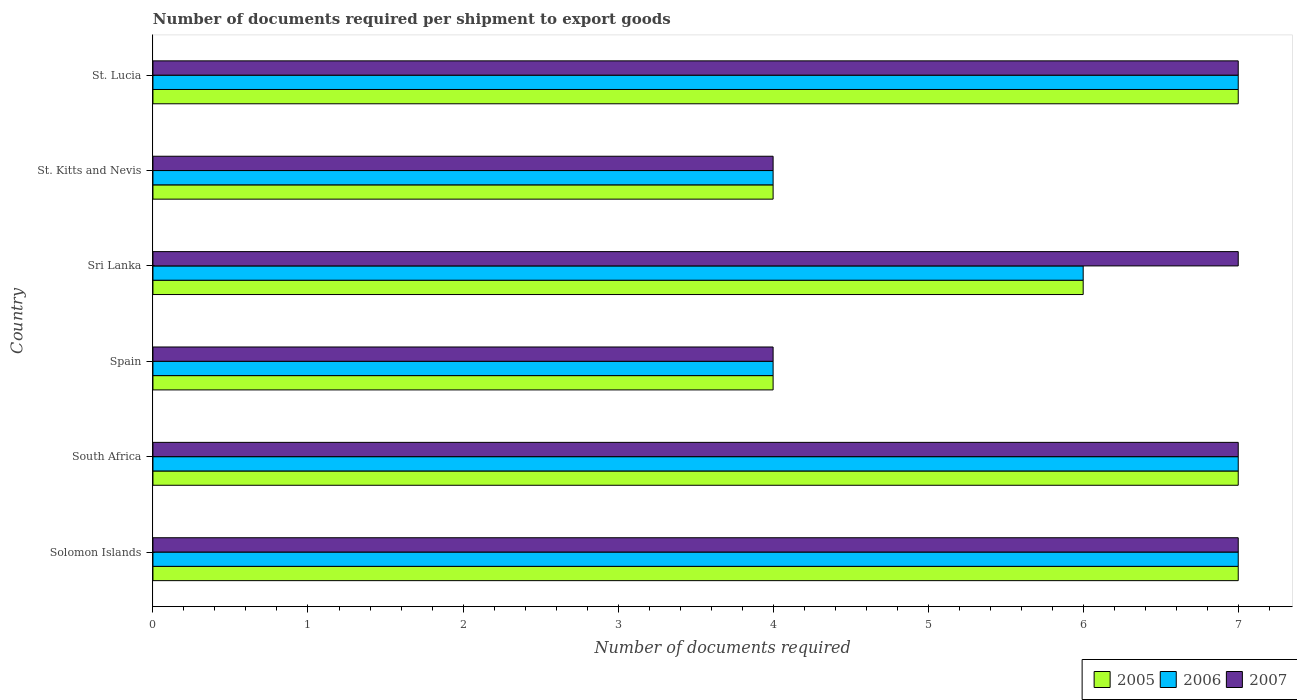How many groups of bars are there?
Provide a short and direct response. 6. Are the number of bars per tick equal to the number of legend labels?
Your response must be concise. Yes. Are the number of bars on each tick of the Y-axis equal?
Ensure brevity in your answer.  Yes. How many bars are there on the 5th tick from the top?
Ensure brevity in your answer.  3. How many bars are there on the 6th tick from the bottom?
Provide a succinct answer. 3. What is the label of the 6th group of bars from the top?
Your answer should be compact. Solomon Islands. In how many cases, is the number of bars for a given country not equal to the number of legend labels?
Give a very brief answer. 0. In which country was the number of documents required per shipment to export goods in 2006 maximum?
Make the answer very short. Solomon Islands. In which country was the number of documents required per shipment to export goods in 2006 minimum?
Offer a very short reply. Spain. What is the total number of documents required per shipment to export goods in 2007 in the graph?
Your answer should be very brief. 36. What is the difference between the number of documents required per shipment to export goods in 2006 in Solomon Islands and that in St. Kitts and Nevis?
Offer a very short reply. 3. What is the difference between the number of documents required per shipment to export goods in 2006 in Sri Lanka and the number of documents required per shipment to export goods in 2005 in St. Kitts and Nevis?
Provide a short and direct response. 2. What is the average number of documents required per shipment to export goods in 2005 per country?
Ensure brevity in your answer.  5.83. What is the difference between the number of documents required per shipment to export goods in 2006 and number of documents required per shipment to export goods in 2007 in St. Lucia?
Your answer should be compact. 0. What is the difference between the highest and the lowest number of documents required per shipment to export goods in 2006?
Give a very brief answer. 3. Is the sum of the number of documents required per shipment to export goods in 2006 in St. Kitts and Nevis and St. Lucia greater than the maximum number of documents required per shipment to export goods in 2007 across all countries?
Make the answer very short. Yes. What does the 1st bar from the bottom in Spain represents?
Your answer should be very brief. 2005. How many bars are there?
Give a very brief answer. 18. Are the values on the major ticks of X-axis written in scientific E-notation?
Offer a very short reply. No. How many legend labels are there?
Provide a succinct answer. 3. How are the legend labels stacked?
Provide a short and direct response. Horizontal. What is the title of the graph?
Your answer should be compact. Number of documents required per shipment to export goods. Does "2001" appear as one of the legend labels in the graph?
Provide a short and direct response. No. What is the label or title of the X-axis?
Your answer should be very brief. Number of documents required. What is the Number of documents required of 2005 in Solomon Islands?
Give a very brief answer. 7. What is the Number of documents required in 2006 in Solomon Islands?
Your response must be concise. 7. What is the Number of documents required of 2005 in South Africa?
Provide a short and direct response. 7. What is the Number of documents required in 2005 in Spain?
Provide a succinct answer. 4. What is the Number of documents required of 2006 in Spain?
Provide a short and direct response. 4. What is the Number of documents required of 2007 in Spain?
Make the answer very short. 4. What is the Number of documents required of 2005 in Sri Lanka?
Provide a succinct answer. 6. What is the Number of documents required of 2006 in St. Kitts and Nevis?
Provide a succinct answer. 4. What is the Number of documents required of 2005 in St. Lucia?
Offer a very short reply. 7. What is the Number of documents required of 2007 in St. Lucia?
Your answer should be compact. 7. Across all countries, what is the maximum Number of documents required of 2005?
Offer a very short reply. 7. Across all countries, what is the minimum Number of documents required in 2006?
Provide a short and direct response. 4. What is the total Number of documents required of 2005 in the graph?
Ensure brevity in your answer.  35. What is the total Number of documents required in 2007 in the graph?
Provide a short and direct response. 36. What is the difference between the Number of documents required in 2005 in Solomon Islands and that in Spain?
Provide a short and direct response. 3. What is the difference between the Number of documents required of 2007 in Solomon Islands and that in Spain?
Offer a very short reply. 3. What is the difference between the Number of documents required of 2006 in Solomon Islands and that in Sri Lanka?
Provide a succinct answer. 1. What is the difference between the Number of documents required in 2005 in Solomon Islands and that in St. Kitts and Nevis?
Your response must be concise. 3. What is the difference between the Number of documents required of 2007 in Solomon Islands and that in St. Kitts and Nevis?
Offer a terse response. 3. What is the difference between the Number of documents required of 2007 in Solomon Islands and that in St. Lucia?
Offer a very short reply. 0. What is the difference between the Number of documents required in 2005 in South Africa and that in Spain?
Make the answer very short. 3. What is the difference between the Number of documents required of 2006 in South Africa and that in Spain?
Your response must be concise. 3. What is the difference between the Number of documents required of 2007 in South Africa and that in Spain?
Keep it short and to the point. 3. What is the difference between the Number of documents required in 2005 in South Africa and that in Sri Lanka?
Keep it short and to the point. 1. What is the difference between the Number of documents required of 2005 in South Africa and that in St. Kitts and Nevis?
Your response must be concise. 3. What is the difference between the Number of documents required of 2005 in South Africa and that in St. Lucia?
Make the answer very short. 0. What is the difference between the Number of documents required of 2006 in South Africa and that in St. Lucia?
Make the answer very short. 0. What is the difference between the Number of documents required in 2005 in Spain and that in Sri Lanka?
Offer a terse response. -2. What is the difference between the Number of documents required of 2005 in Spain and that in St. Kitts and Nevis?
Ensure brevity in your answer.  0. What is the difference between the Number of documents required in 2006 in Sri Lanka and that in St. Kitts and Nevis?
Offer a terse response. 2. What is the difference between the Number of documents required of 2006 in Sri Lanka and that in St. Lucia?
Provide a succinct answer. -1. What is the difference between the Number of documents required of 2007 in Sri Lanka and that in St. Lucia?
Give a very brief answer. 0. What is the difference between the Number of documents required of 2005 in St. Kitts and Nevis and that in St. Lucia?
Give a very brief answer. -3. What is the difference between the Number of documents required of 2006 in St. Kitts and Nevis and that in St. Lucia?
Give a very brief answer. -3. What is the difference between the Number of documents required of 2005 in Solomon Islands and the Number of documents required of 2007 in South Africa?
Make the answer very short. 0. What is the difference between the Number of documents required of 2006 in Solomon Islands and the Number of documents required of 2007 in South Africa?
Your response must be concise. 0. What is the difference between the Number of documents required of 2005 in Solomon Islands and the Number of documents required of 2007 in Spain?
Offer a very short reply. 3. What is the difference between the Number of documents required in 2006 in Solomon Islands and the Number of documents required in 2007 in Sri Lanka?
Make the answer very short. 0. What is the difference between the Number of documents required in 2005 in Solomon Islands and the Number of documents required in 2006 in St. Kitts and Nevis?
Provide a short and direct response. 3. What is the difference between the Number of documents required of 2005 in South Africa and the Number of documents required of 2006 in Spain?
Offer a very short reply. 3. What is the difference between the Number of documents required of 2005 in South Africa and the Number of documents required of 2007 in Spain?
Give a very brief answer. 3. What is the difference between the Number of documents required of 2006 in South Africa and the Number of documents required of 2007 in Spain?
Provide a succinct answer. 3. What is the difference between the Number of documents required of 2005 in South Africa and the Number of documents required of 2007 in Sri Lanka?
Provide a short and direct response. 0. What is the difference between the Number of documents required in 2005 in South Africa and the Number of documents required in 2006 in St. Kitts and Nevis?
Make the answer very short. 3. What is the difference between the Number of documents required of 2005 in South Africa and the Number of documents required of 2007 in St. Kitts and Nevis?
Offer a very short reply. 3. What is the difference between the Number of documents required in 2005 in South Africa and the Number of documents required in 2006 in St. Lucia?
Make the answer very short. 0. What is the difference between the Number of documents required in 2006 in South Africa and the Number of documents required in 2007 in St. Lucia?
Keep it short and to the point. 0. What is the difference between the Number of documents required of 2005 in Spain and the Number of documents required of 2006 in Sri Lanka?
Provide a succinct answer. -2. What is the difference between the Number of documents required in 2006 in Spain and the Number of documents required in 2007 in Sri Lanka?
Make the answer very short. -3. What is the difference between the Number of documents required in 2006 in Spain and the Number of documents required in 2007 in St. Kitts and Nevis?
Make the answer very short. 0. What is the difference between the Number of documents required of 2006 in Spain and the Number of documents required of 2007 in St. Lucia?
Offer a very short reply. -3. What is the difference between the Number of documents required of 2005 in Sri Lanka and the Number of documents required of 2007 in St. Kitts and Nevis?
Your answer should be compact. 2. What is the difference between the Number of documents required of 2006 in Sri Lanka and the Number of documents required of 2007 in St. Kitts and Nevis?
Your response must be concise. 2. What is the difference between the Number of documents required in 2005 in Sri Lanka and the Number of documents required in 2006 in St. Lucia?
Provide a short and direct response. -1. What is the difference between the Number of documents required in 2005 in Sri Lanka and the Number of documents required in 2007 in St. Lucia?
Offer a terse response. -1. What is the difference between the Number of documents required of 2006 in Sri Lanka and the Number of documents required of 2007 in St. Lucia?
Make the answer very short. -1. What is the difference between the Number of documents required in 2005 in St. Kitts and Nevis and the Number of documents required in 2007 in St. Lucia?
Give a very brief answer. -3. What is the difference between the Number of documents required of 2006 in St. Kitts and Nevis and the Number of documents required of 2007 in St. Lucia?
Your answer should be compact. -3. What is the average Number of documents required in 2005 per country?
Provide a succinct answer. 5.83. What is the average Number of documents required of 2006 per country?
Your response must be concise. 5.83. What is the difference between the Number of documents required of 2005 and Number of documents required of 2007 in Solomon Islands?
Keep it short and to the point. 0. What is the difference between the Number of documents required of 2006 and Number of documents required of 2007 in Solomon Islands?
Make the answer very short. 0. What is the difference between the Number of documents required of 2005 and Number of documents required of 2006 in South Africa?
Give a very brief answer. 0. What is the difference between the Number of documents required in 2005 and Number of documents required in 2007 in South Africa?
Your answer should be very brief. 0. What is the difference between the Number of documents required of 2006 and Number of documents required of 2007 in Spain?
Your answer should be very brief. 0. What is the difference between the Number of documents required of 2005 and Number of documents required of 2007 in Sri Lanka?
Offer a very short reply. -1. What is the difference between the Number of documents required of 2005 and Number of documents required of 2006 in St. Kitts and Nevis?
Give a very brief answer. 0. What is the difference between the Number of documents required of 2006 and Number of documents required of 2007 in St. Kitts and Nevis?
Keep it short and to the point. 0. What is the difference between the Number of documents required of 2005 and Number of documents required of 2006 in St. Lucia?
Make the answer very short. 0. What is the ratio of the Number of documents required of 2005 in Solomon Islands to that in Spain?
Provide a short and direct response. 1.75. What is the ratio of the Number of documents required of 2006 in Solomon Islands to that in Spain?
Keep it short and to the point. 1.75. What is the ratio of the Number of documents required of 2007 in Solomon Islands to that in Spain?
Provide a succinct answer. 1.75. What is the ratio of the Number of documents required in 2005 in Solomon Islands to that in Sri Lanka?
Make the answer very short. 1.17. What is the ratio of the Number of documents required in 2006 in Solomon Islands to that in Sri Lanka?
Offer a terse response. 1.17. What is the ratio of the Number of documents required of 2005 in Solomon Islands to that in St. Kitts and Nevis?
Offer a very short reply. 1.75. What is the ratio of the Number of documents required in 2006 in Solomon Islands to that in St. Kitts and Nevis?
Your answer should be compact. 1.75. What is the ratio of the Number of documents required of 2007 in Solomon Islands to that in St. Kitts and Nevis?
Keep it short and to the point. 1.75. What is the ratio of the Number of documents required of 2005 in Solomon Islands to that in St. Lucia?
Give a very brief answer. 1. What is the ratio of the Number of documents required in 2006 in South Africa to that in Spain?
Keep it short and to the point. 1.75. What is the ratio of the Number of documents required in 2007 in South Africa to that in Spain?
Give a very brief answer. 1.75. What is the ratio of the Number of documents required of 2005 in South Africa to that in Sri Lanka?
Your response must be concise. 1.17. What is the ratio of the Number of documents required in 2007 in South Africa to that in Sri Lanka?
Provide a short and direct response. 1. What is the ratio of the Number of documents required in 2005 in South Africa to that in St. Kitts and Nevis?
Keep it short and to the point. 1.75. What is the ratio of the Number of documents required in 2007 in South Africa to that in St. Kitts and Nevis?
Provide a short and direct response. 1.75. What is the ratio of the Number of documents required in 2007 in Spain to that in Sri Lanka?
Make the answer very short. 0.57. What is the ratio of the Number of documents required in 2005 in Spain to that in St. Lucia?
Offer a terse response. 0.57. What is the ratio of the Number of documents required of 2007 in Spain to that in St. Lucia?
Offer a very short reply. 0.57. What is the ratio of the Number of documents required of 2005 in Sri Lanka to that in St. Kitts and Nevis?
Provide a succinct answer. 1.5. What is the ratio of the Number of documents required in 2006 in Sri Lanka to that in St. Kitts and Nevis?
Your response must be concise. 1.5. What is the ratio of the Number of documents required in 2007 in Sri Lanka to that in St. Kitts and Nevis?
Your answer should be very brief. 1.75. What is the ratio of the Number of documents required in 2006 in Sri Lanka to that in St. Lucia?
Your response must be concise. 0.86. What is the ratio of the Number of documents required of 2006 in St. Kitts and Nevis to that in St. Lucia?
Give a very brief answer. 0.57. What is the difference between the highest and the second highest Number of documents required in 2005?
Ensure brevity in your answer.  0. What is the difference between the highest and the second highest Number of documents required of 2006?
Your response must be concise. 0. What is the difference between the highest and the lowest Number of documents required of 2005?
Your response must be concise. 3. What is the difference between the highest and the lowest Number of documents required of 2006?
Your answer should be very brief. 3. 